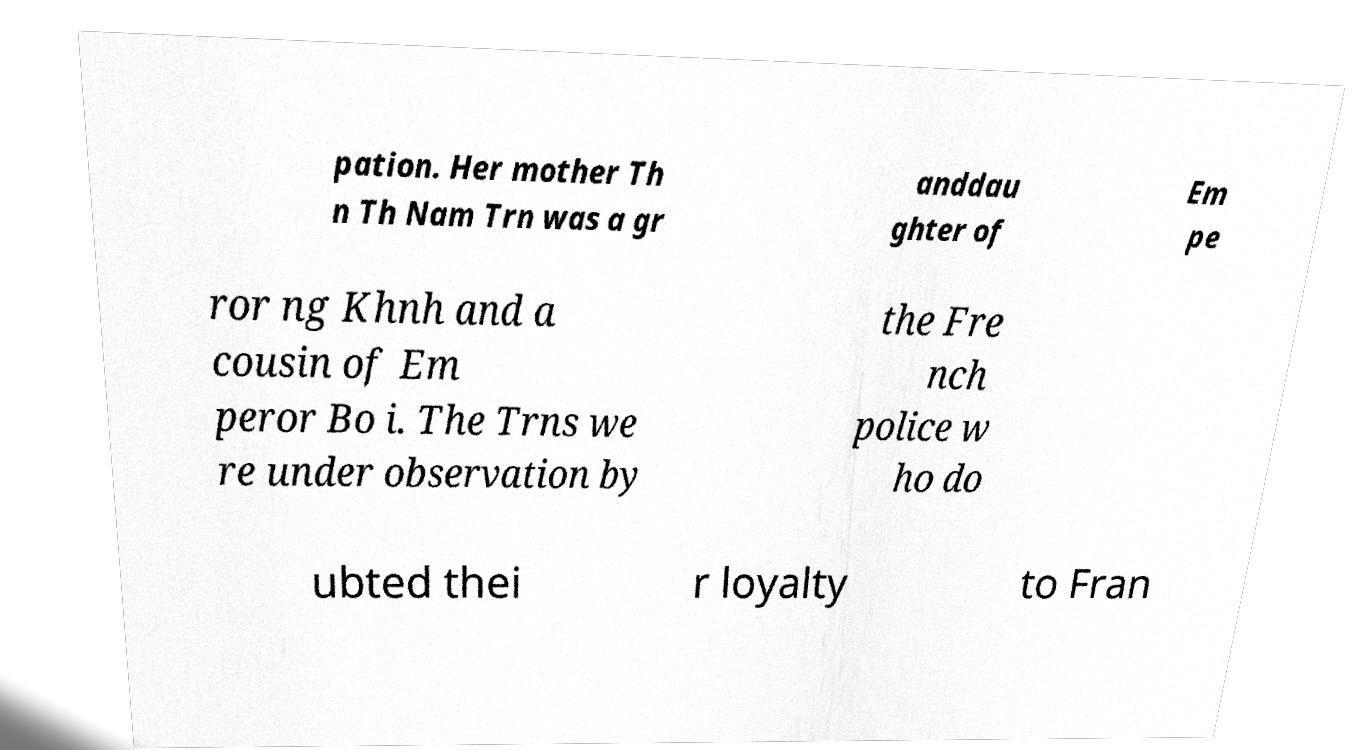Can you accurately transcribe the text from the provided image for me? pation. Her mother Th n Th Nam Trn was a gr anddau ghter of Em pe ror ng Khnh and a cousin of Em peror Bo i. The Trns we re under observation by the Fre nch police w ho do ubted thei r loyalty to Fran 